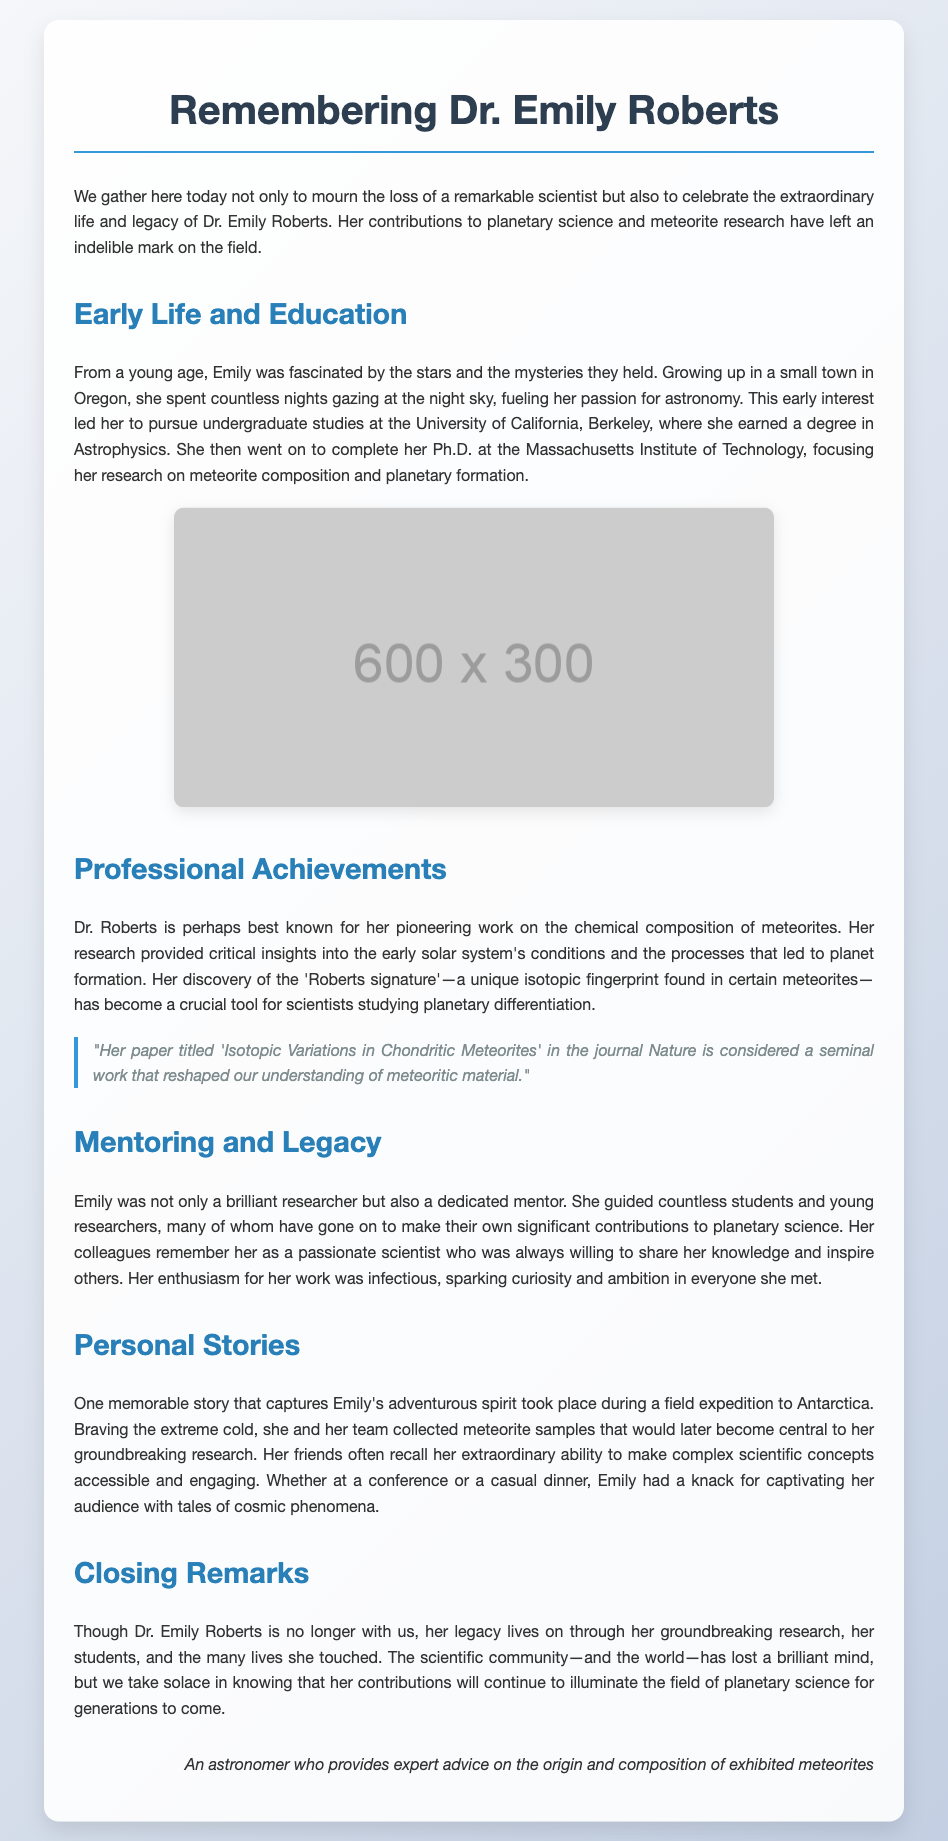What degree did Emily earn for her undergraduate studies? The document states that she earned a degree in Astrophysics from the University of California, Berkeley.
Answer: Astrophysics What is the title of Emily's seminal paper? The document mentions her paper titled 'Isotopic Variations in Chondritic Meteorites' in the journal Nature.
Answer: 'Isotopic Variations in Chondritic Meteorites' What is the 'Roberts signature'? The text describes the 'Roberts signature' as a unique isotopic fingerprint found in certain meteorites that she discovered.
Answer: Unique isotopic fingerprint In which location did Dr. Emily Roberts conduct a field expedition? The document refers to her field expedition taking place in Antarctica.
Answer: Antarctica How did Emily's colleagues describe her as a mentor? The text reflects that her colleagues remembered her as a passionate scientist who was always willing to share her knowledge.
Answer: Passionate scientist What was the primary focus of Emily's Ph.D. research? The document states that she focused her research on meteorite composition and planetary formation.
Answer: Meteorite composition and planetary formation Which educational institution did Emily attend for her Ph.D.? The document lists the Massachusetts Institute of Technology as the institution where she completed her Ph.D.
Answer: Massachusetts Institute of Technology How is Emily's legacy conveyed in the document? The document emphasizes that her legacy lives on through her groundbreaking research, her students, and the many lives she touched.
Answer: Groundbreaking research, students, and lives touched 